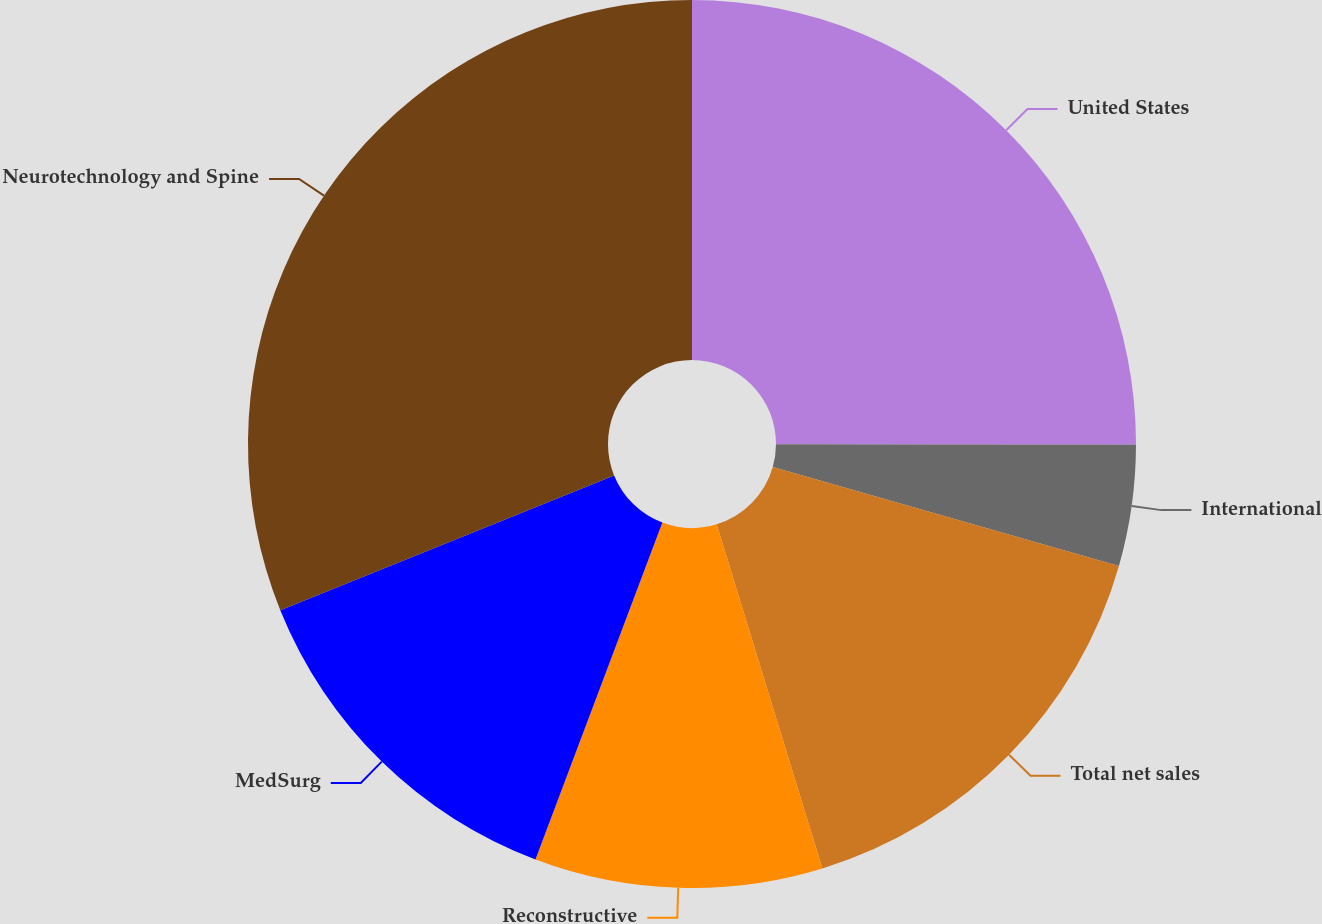<chart> <loc_0><loc_0><loc_500><loc_500><pie_chart><fcel>United States<fcel>International<fcel>Total net sales<fcel>Reconstructive<fcel>MedSurg<fcel>Neurotechnology and Spine<nl><fcel>25.03%<fcel>4.4%<fcel>15.83%<fcel>10.48%<fcel>13.16%<fcel>31.11%<nl></chart> 